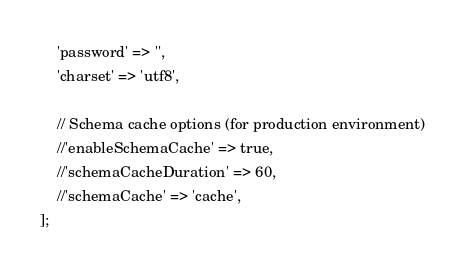<code> <loc_0><loc_0><loc_500><loc_500><_PHP_>    'password' => '',
    'charset' => 'utf8',

    // Schema cache options (for production environment)
    //'enableSchemaCache' => true,
    //'schemaCacheDuration' => 60,
    //'schemaCache' => 'cache',
];
</code> 